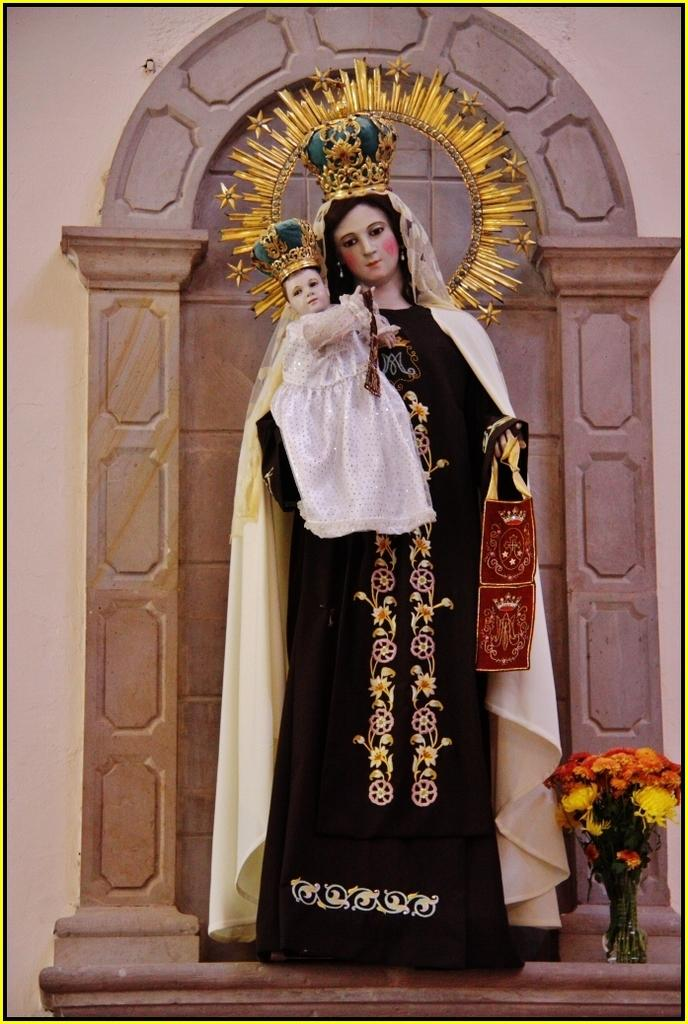What is the main subject of the image? There is a statue of a lady in the image. What is the lady wearing? The lady is wearing a black gown. What is the lady holding? The lady is holding a baby. What can be seen in the bottom right corner of the image? There is a flower pot in the right bottom of the image. What is visible in the background of the image? There is a wall in the background of the image. Can you see any docks in the image? There are no docks present in the image. What color is the orange in the image? There is no orange present in the image. 